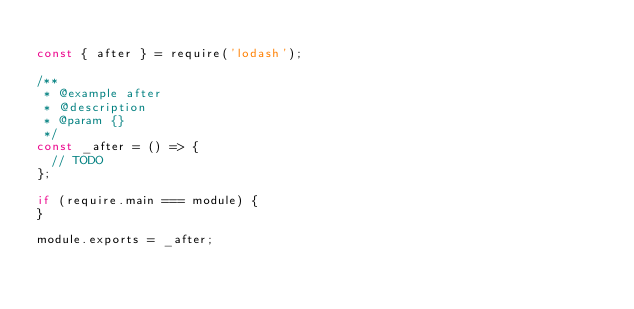Convert code to text. <code><loc_0><loc_0><loc_500><loc_500><_JavaScript_>
const { after } = require('lodash');

/**
 * @example after
 * @description 
 * @param {} 
 */
const _after = () => {
  // TODO
};

if (require.main === module) {
}

module.exports = _after;
</code> 